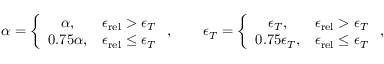<formula> <loc_0><loc_0><loc_500><loc_500>\alpha = \left \{ \begin{array} { c c } { \alpha , } & { { \epsilon _ { r e l } } > \epsilon _ { T } } \\ { 0 . 7 5 \alpha , } & { { \epsilon _ { r e l } } \leq \epsilon _ { T } } \end{array} , \quad \epsilon _ { T } = \left \{ \begin{array} { c c } { \epsilon _ { T } , } & { { \epsilon _ { r e l } } > \epsilon _ { T } } \\ { 0 . 7 5 \epsilon _ { T } , } & { { \epsilon _ { r e l } } \leq \epsilon _ { T } } \end{array} ,</formula> 